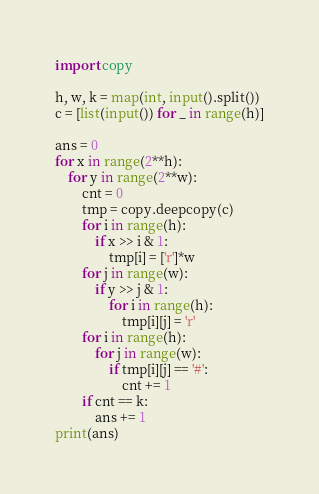<code> <loc_0><loc_0><loc_500><loc_500><_Python_>import copy

h, w, k = map(int, input().split())
c = [list(input()) for _ in range(h)]

ans = 0
for x in range(2**h):
    for y in range(2**w):
        cnt = 0
        tmp = copy.deepcopy(c)
        for i in range(h):
            if x >> i & 1:
                tmp[i] = ['r']*w
        for j in range(w):
            if y >> j & 1:
                for i in range(h):
                    tmp[i][j] = 'r'
        for i in range(h):
            for j in range(w):
                if tmp[i][j] == '#':
                    cnt += 1
        if cnt == k:
            ans += 1
print(ans)</code> 